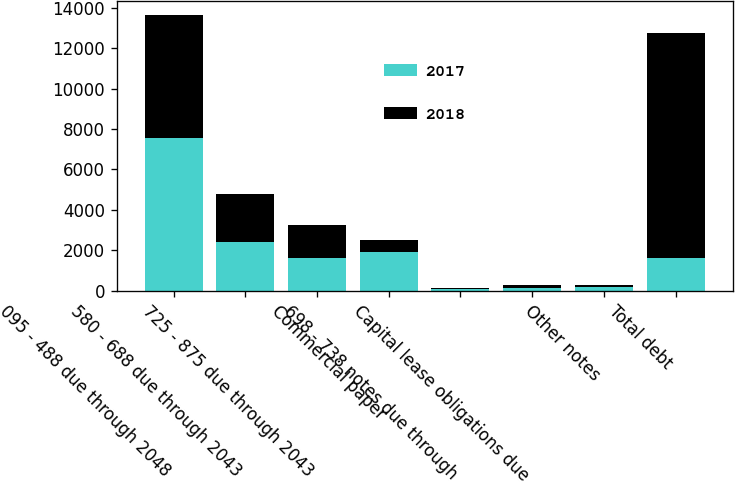Convert chart to OTSL. <chart><loc_0><loc_0><loc_500><loc_500><stacked_bar_chart><ecel><fcel>095 - 488 due through 2048<fcel>580 - 688 due through 2043<fcel>725 - 875 due through 2043<fcel>Commercial paper<fcel>698 - 738 notes due through<fcel>Capital lease obligations due<fcel>Other notes<fcel>Total debt<nl><fcel>2017<fcel>7538<fcel>2388<fcel>1638<fcel>1895<fcel>62<fcel>156<fcel>170<fcel>1637<nl><fcel>2018<fcel>6127<fcel>2386<fcel>1637<fcel>600<fcel>94<fcel>138<fcel>135<fcel>11117<nl></chart> 